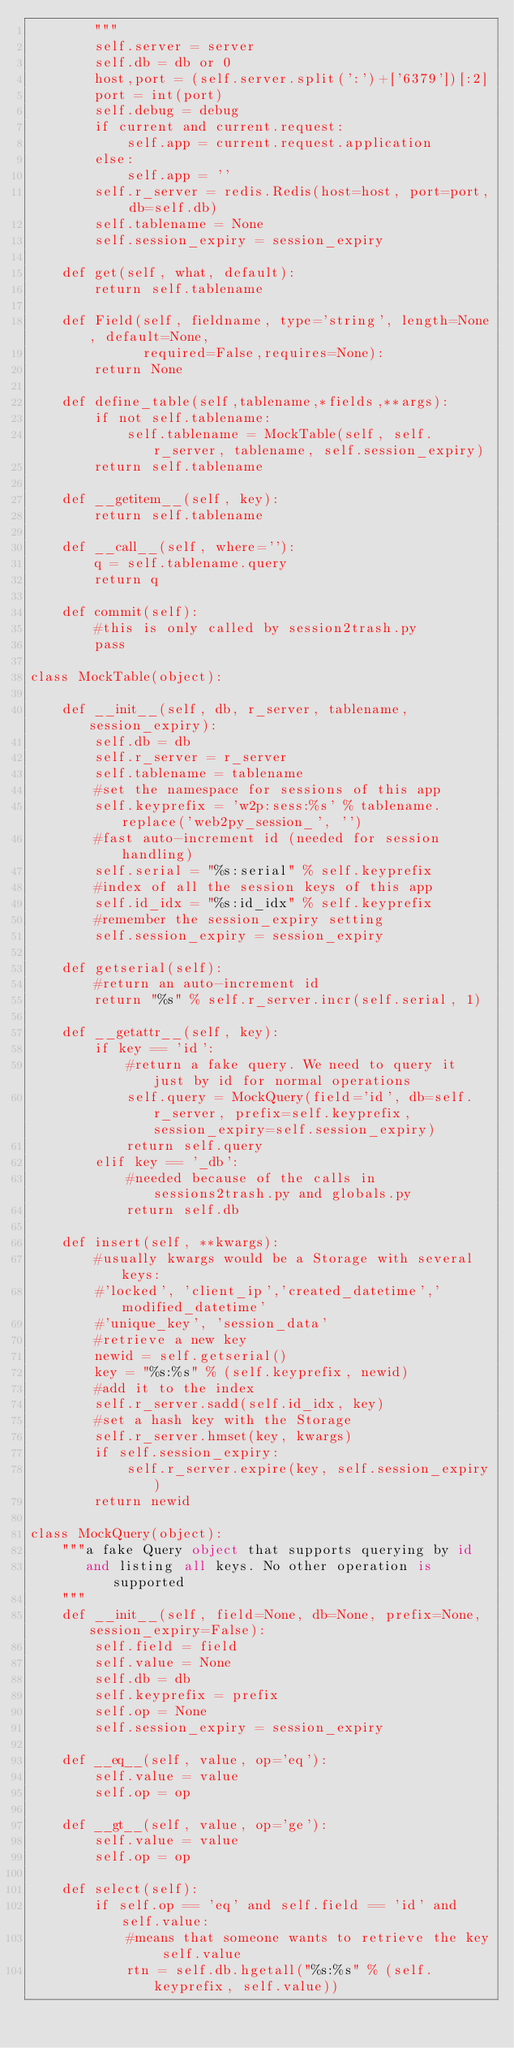Convert code to text. <code><loc_0><loc_0><loc_500><loc_500><_Python_>        """
        self.server = server
        self.db = db or 0
        host,port = (self.server.split(':')+['6379'])[:2]
        port = int(port)
        self.debug = debug
        if current and current.request:
            self.app = current.request.application
        else:
            self.app = ''
        self.r_server = redis.Redis(host=host, port=port, db=self.db)
        self.tablename = None
        self.session_expiry = session_expiry

    def get(self, what, default):
        return self.tablename

    def Field(self, fieldname, type='string', length=None, default=None,
              required=False,requires=None):
        return None

    def define_table(self,tablename,*fields,**args):
        if not self.tablename:
            self.tablename = MockTable(self, self.r_server, tablename, self.session_expiry)
        return self.tablename

    def __getitem__(self, key):
        return self.tablename

    def __call__(self, where=''):
        q = self.tablename.query
        return q

    def commit(self):
        #this is only called by session2trash.py
        pass

class MockTable(object):

    def __init__(self, db, r_server, tablename, session_expiry):
        self.db = db
        self.r_server = r_server
        self.tablename = tablename
        #set the namespace for sessions of this app
        self.keyprefix = 'w2p:sess:%s' % tablename.replace('web2py_session_', '')
        #fast auto-increment id (needed for session handling)
        self.serial = "%s:serial" % self.keyprefix
        #index of all the session keys of this app
        self.id_idx = "%s:id_idx" % self.keyprefix
        #remember the session_expiry setting
        self.session_expiry = session_expiry

    def getserial(self):
        #return an auto-increment id
        return "%s" % self.r_server.incr(self.serial, 1)

    def __getattr__(self, key):
        if key == 'id':
            #return a fake query. We need to query it just by id for normal operations
            self.query = MockQuery(field='id', db=self.r_server, prefix=self.keyprefix, session_expiry=self.session_expiry)
            return self.query
        elif key == '_db':
            #needed because of the calls in sessions2trash.py and globals.py
            return self.db

    def insert(self, **kwargs):
        #usually kwargs would be a Storage with several keys:
        #'locked', 'client_ip','created_datetime','modified_datetime'
        #'unique_key', 'session_data'
        #retrieve a new key
        newid = self.getserial()
        key = "%s:%s" % (self.keyprefix, newid)
        #add it to the index
        self.r_server.sadd(self.id_idx, key)
        #set a hash key with the Storage
        self.r_server.hmset(key, kwargs)
        if self.session_expiry:
            self.r_server.expire(key, self.session_expiry)
        return newid

class MockQuery(object):
    """a fake Query object that supports querying by id
       and listing all keys. No other operation is supported 
    """
    def __init__(self, field=None, db=None, prefix=None, session_expiry=False):
        self.field = field
        self.value = None
        self.db = db
        self.keyprefix = prefix
        self.op = None
        self.session_expiry = session_expiry

    def __eq__(self, value, op='eq'):
        self.value = value
        self.op = op

    def __gt__(self, value, op='ge'):
        self.value = value
        self.op = op

    def select(self):
        if self.op == 'eq' and self.field == 'id' and self.value:
            #means that someone wants to retrieve the key self.value
            rtn = self.db.hgetall("%s:%s" % (self.keyprefix, self.value))</code> 